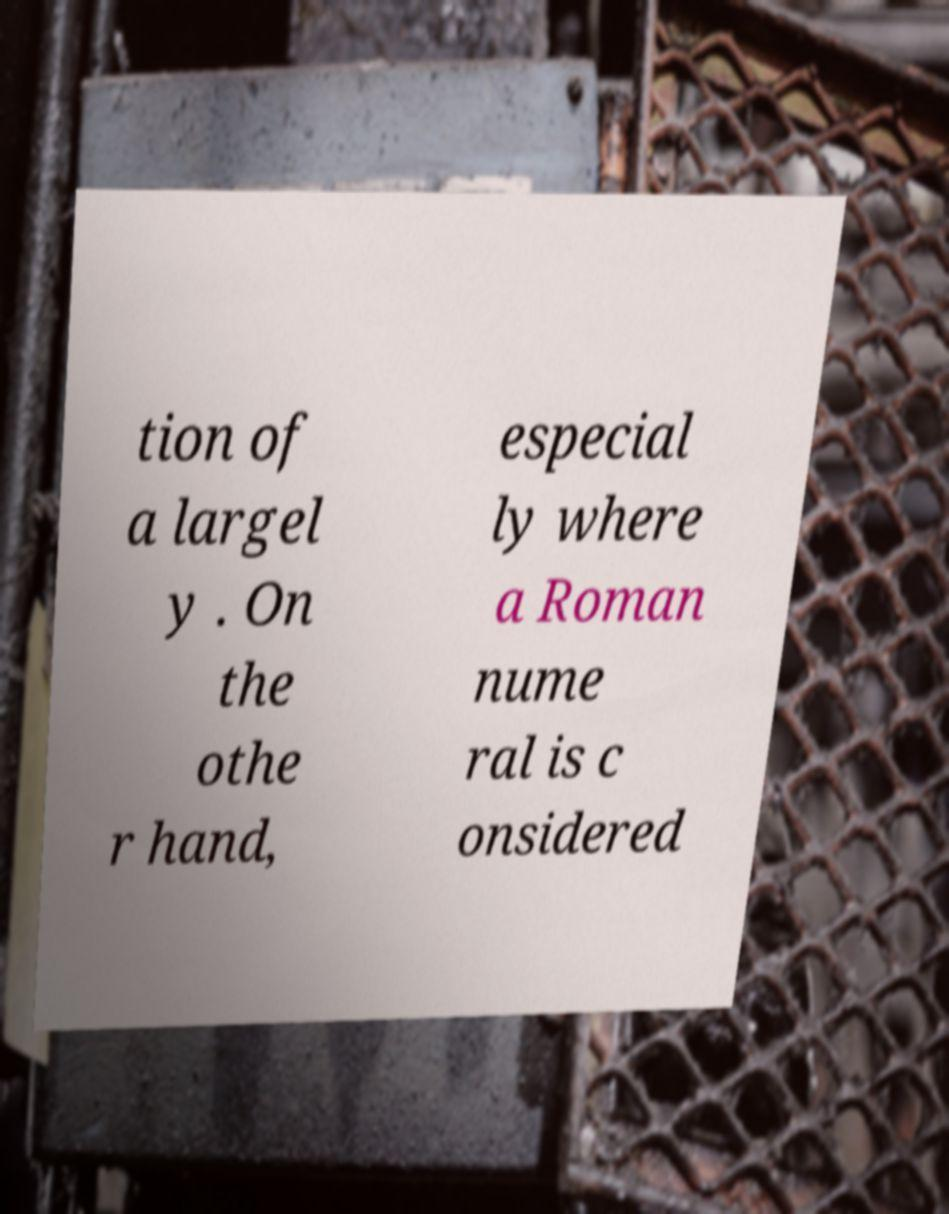Could you extract and type out the text from this image? tion of a largel y . On the othe r hand, especial ly where a Roman nume ral is c onsidered 